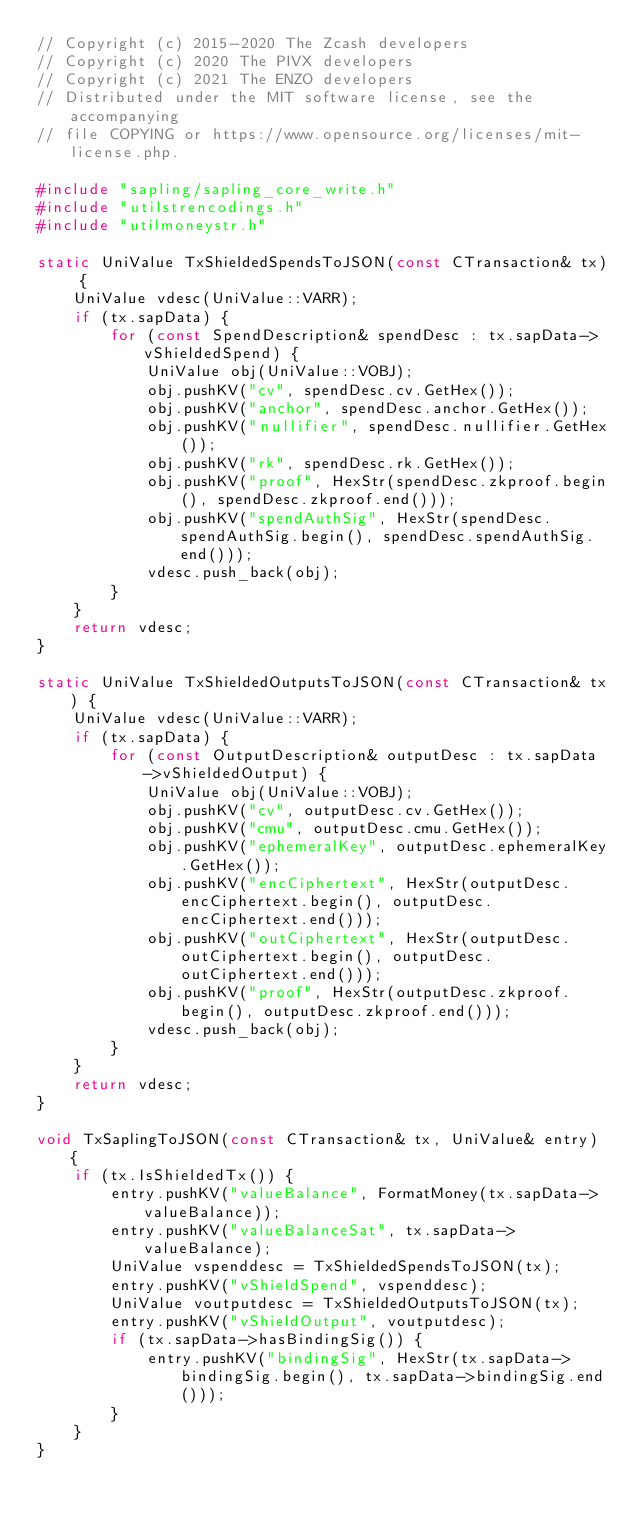Convert code to text. <code><loc_0><loc_0><loc_500><loc_500><_C++_>// Copyright (c) 2015-2020 The Zcash developers
// Copyright (c) 2020 The PIVX developers
// Copyright (c) 2021 The ENZO developers
// Distributed under the MIT software license, see the accompanying
// file COPYING or https://www.opensource.org/licenses/mit-license.php.

#include "sapling/sapling_core_write.h"
#include "utilstrencodings.h"
#include "utilmoneystr.h"

static UniValue TxShieldedSpendsToJSON(const CTransaction& tx) {
    UniValue vdesc(UniValue::VARR);
    if (tx.sapData) {
        for (const SpendDescription& spendDesc : tx.sapData->vShieldedSpend) {
            UniValue obj(UniValue::VOBJ);
            obj.pushKV("cv", spendDesc.cv.GetHex());
            obj.pushKV("anchor", spendDesc.anchor.GetHex());
            obj.pushKV("nullifier", spendDesc.nullifier.GetHex());
            obj.pushKV("rk", spendDesc.rk.GetHex());
            obj.pushKV("proof", HexStr(spendDesc.zkproof.begin(), spendDesc.zkproof.end()));
            obj.pushKV("spendAuthSig", HexStr(spendDesc.spendAuthSig.begin(), spendDesc.spendAuthSig.end()));
            vdesc.push_back(obj);
        }
    }
    return vdesc;
}

static UniValue TxShieldedOutputsToJSON(const CTransaction& tx) {
    UniValue vdesc(UniValue::VARR);
    if (tx.sapData) {
        for (const OutputDescription& outputDesc : tx.sapData->vShieldedOutput) {
            UniValue obj(UniValue::VOBJ);
            obj.pushKV("cv", outputDesc.cv.GetHex());
            obj.pushKV("cmu", outputDesc.cmu.GetHex());
            obj.pushKV("ephemeralKey", outputDesc.ephemeralKey.GetHex());
            obj.pushKV("encCiphertext", HexStr(outputDesc.encCiphertext.begin(), outputDesc.encCiphertext.end()));
            obj.pushKV("outCiphertext", HexStr(outputDesc.outCiphertext.begin(), outputDesc.outCiphertext.end()));
            obj.pushKV("proof", HexStr(outputDesc.zkproof.begin(), outputDesc.zkproof.end()));
            vdesc.push_back(obj);
        }
    }
    return vdesc;
}

void TxSaplingToJSON(const CTransaction& tx, UniValue& entry) {
    if (tx.IsShieldedTx()) {
        entry.pushKV("valueBalance", FormatMoney(tx.sapData->valueBalance));
        entry.pushKV("valueBalanceSat", tx.sapData->valueBalance);
        UniValue vspenddesc = TxShieldedSpendsToJSON(tx);
        entry.pushKV("vShieldSpend", vspenddesc);
        UniValue voutputdesc = TxShieldedOutputsToJSON(tx);
        entry.pushKV("vShieldOutput", voutputdesc);
        if (tx.sapData->hasBindingSig()) {
            entry.pushKV("bindingSig", HexStr(tx.sapData->bindingSig.begin(), tx.sapData->bindingSig.end()));
        }
    }
}
</code> 